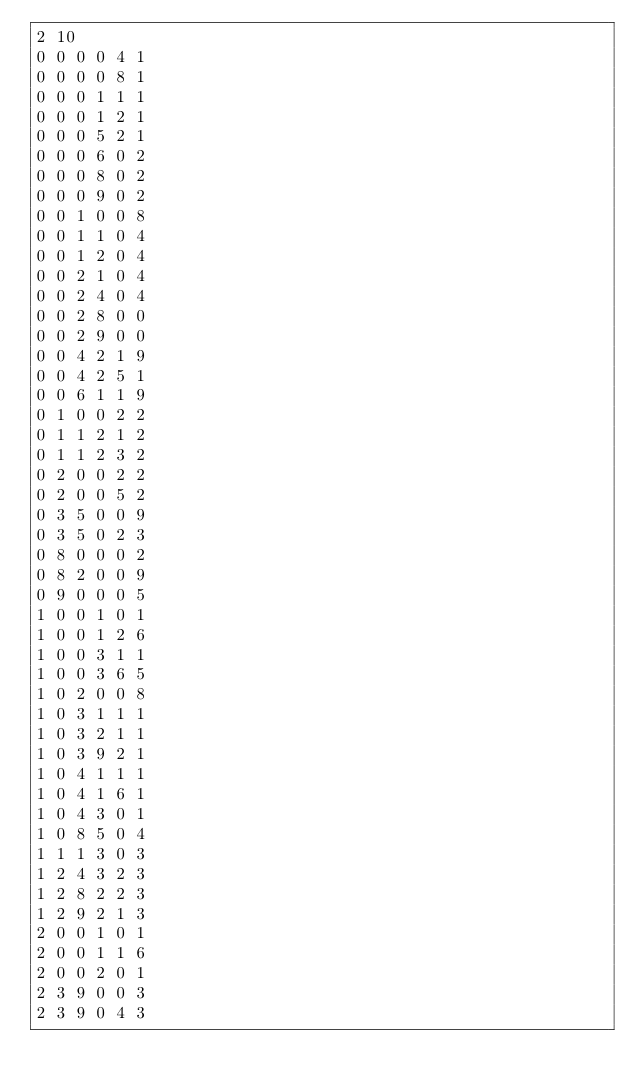<code> <loc_0><loc_0><loc_500><loc_500><_SQL_>2 10
0 0 0 0 4 1
0 0 0 0 8 1
0 0 0 1 1 1
0 0 0 1 2 1
0 0 0 5 2 1
0 0 0 6 0 2
0 0 0 8 0 2
0 0 0 9 0 2
0 0 1 0 0 8
0 0 1 1 0 4
0 0 1 2 0 4
0 0 2 1 0 4
0 0 2 4 0 4
0 0 2 8 0 0
0 0 2 9 0 0
0 0 4 2 1 9
0 0 4 2 5 1
0 0 6 1 1 9
0 1 0 0 2 2
0 1 1 2 1 2
0 1 1 2 3 2
0 2 0 0 2 2
0 2 0 0 5 2
0 3 5 0 0 9
0 3 5 0 2 3
0 8 0 0 0 2
0 8 2 0 0 9
0 9 0 0 0 5
1 0 0 1 0 1
1 0 0 1 2 6
1 0 0 3 1 1
1 0 0 3 6 5
1 0 2 0 0 8
1 0 3 1 1 1
1 0 3 2 1 1
1 0 3 9 2 1
1 0 4 1 1 1
1 0 4 1 6 1
1 0 4 3 0 1
1 0 8 5 0 4
1 1 1 3 0 3
1 2 4 3 2 3
1 2 8 2 2 3
1 2 9 2 1 3
2 0 0 1 0 1
2 0 0 1 1 6
2 0 0 2 0 1
2 3 9 0 0 3
2 3 9 0 4 3</code> 